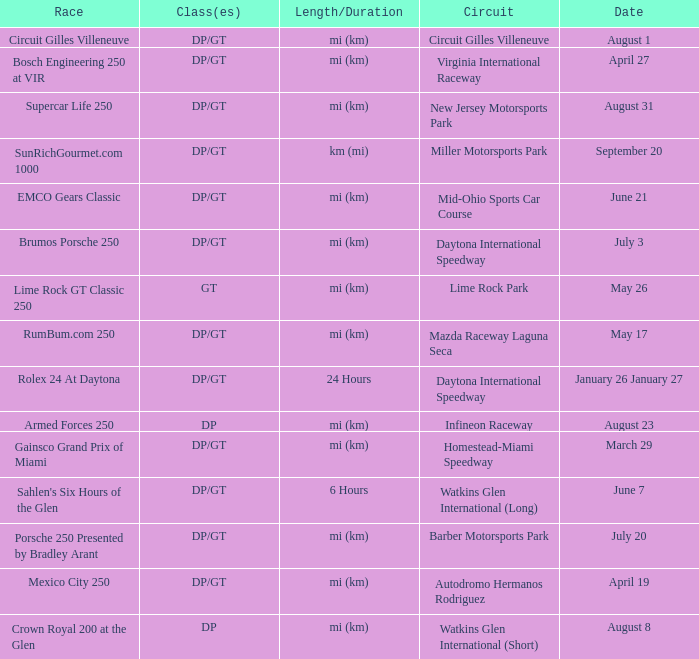What is the length and duration of the race on April 19? Mi (km). 